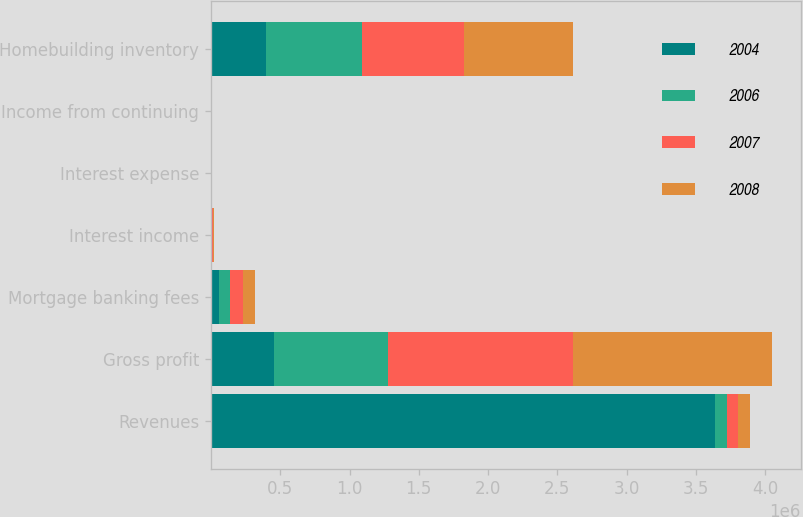Convert chart. <chart><loc_0><loc_0><loc_500><loc_500><stacked_bar_chart><ecel><fcel>Revenues<fcel>Gross profit<fcel>Mortgage banking fees<fcel>Interest income<fcel>Interest expense<fcel>Income from continuing<fcel>Homebuilding inventory<nl><fcel>2004<fcel>3.6387e+06<fcel>457692<fcel>54337<fcel>3955<fcel>754<fcel>17.04<fcel>400570<nl><fcel>2006<fcel>84604<fcel>821128<fcel>81155<fcel>4900<fcel>681<fcel>54.14<fcel>688854<nl><fcel>2007<fcel>84604<fcel>1.33497e+06<fcel>97888<fcel>7704<fcel>2805<fcel>88.05<fcel>733616<nl><fcel>2008<fcel>84604<fcel>1.43971e+06<fcel>84604<fcel>5014<fcel>1759<fcel>89.61<fcel>793975<nl></chart> 